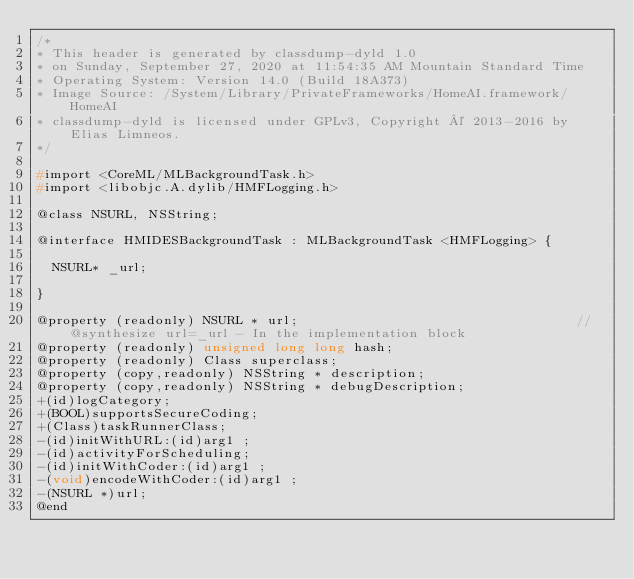Convert code to text. <code><loc_0><loc_0><loc_500><loc_500><_C_>/*
* This header is generated by classdump-dyld 1.0
* on Sunday, September 27, 2020 at 11:54:35 AM Mountain Standard Time
* Operating System: Version 14.0 (Build 18A373)
* Image Source: /System/Library/PrivateFrameworks/HomeAI.framework/HomeAI
* classdump-dyld is licensed under GPLv3, Copyright © 2013-2016 by Elias Limneos.
*/

#import <CoreML/MLBackgroundTask.h>
#import <libobjc.A.dylib/HMFLogging.h>

@class NSURL, NSString;

@interface HMIDESBackgroundTask : MLBackgroundTask <HMFLogging> {

	NSURL* _url;

}

@property (readonly) NSURL * url;                                   //@synthesize url=_url - In the implementation block
@property (readonly) unsigned long long hash; 
@property (readonly) Class superclass; 
@property (copy,readonly) NSString * description; 
@property (copy,readonly) NSString * debugDescription; 
+(id)logCategory;
+(BOOL)supportsSecureCoding;
+(Class)taskRunnerClass;
-(id)initWithURL:(id)arg1 ;
-(id)activityForScheduling;
-(id)initWithCoder:(id)arg1 ;
-(void)encodeWithCoder:(id)arg1 ;
-(NSURL *)url;
@end

</code> 